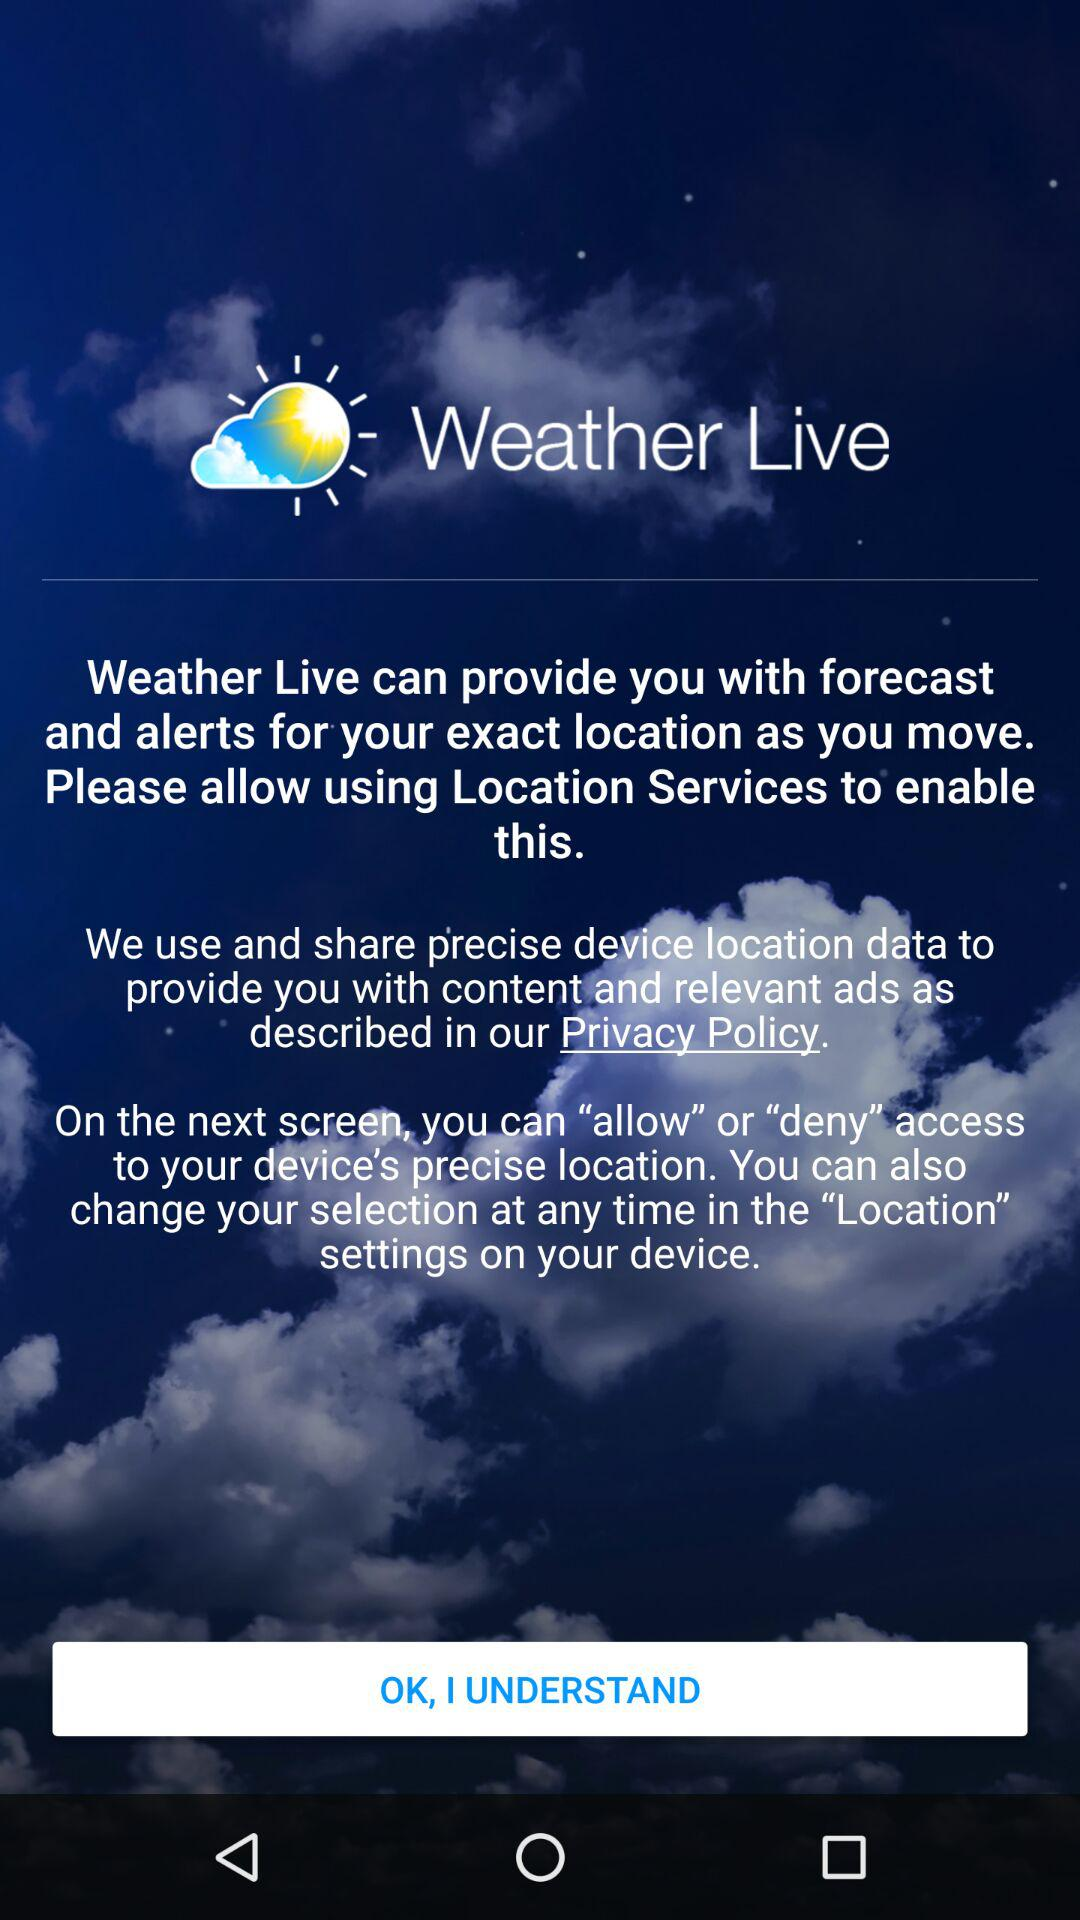Was location access allowed or denied?
When the provided information is insufficient, respond with <no answer>. <no answer> 